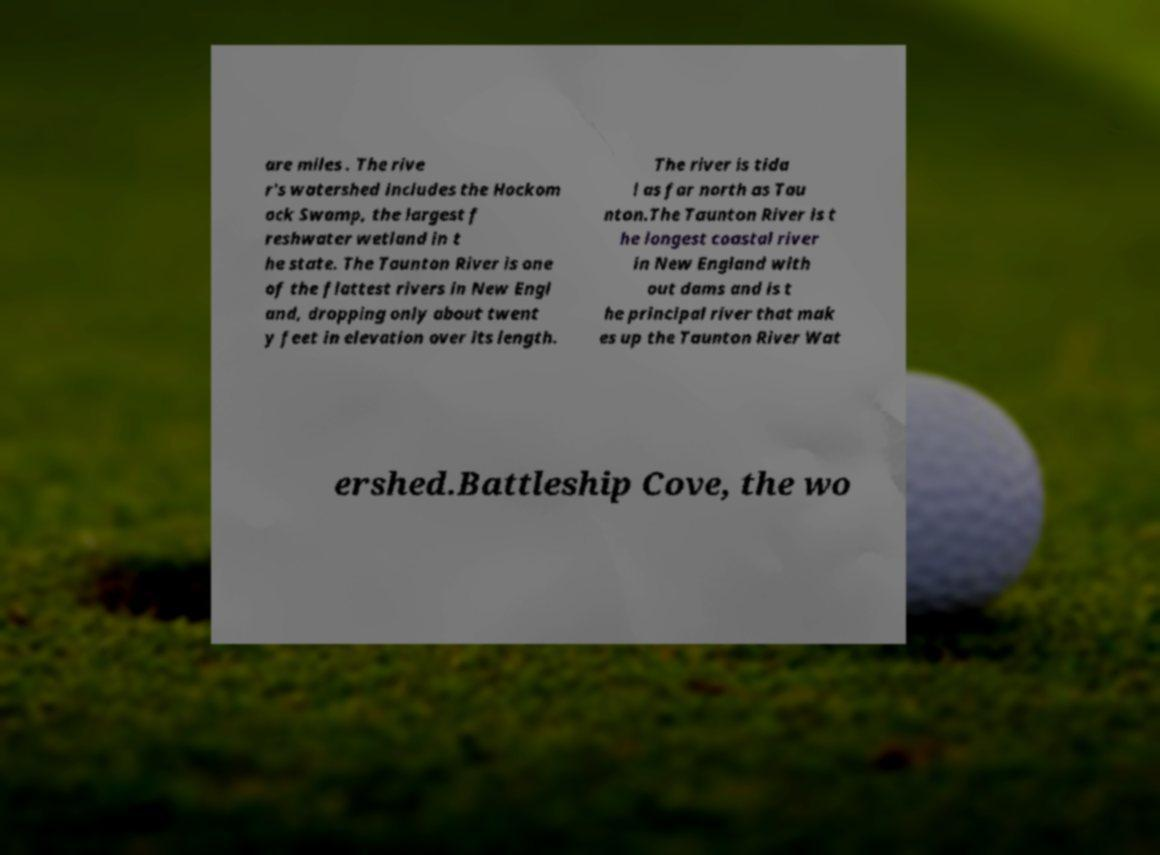For documentation purposes, I need the text within this image transcribed. Could you provide that? are miles . The rive r's watershed includes the Hockom ock Swamp, the largest f reshwater wetland in t he state. The Taunton River is one of the flattest rivers in New Engl and, dropping only about twent y feet in elevation over its length. The river is tida l as far north as Tau nton.The Taunton River is t he longest coastal river in New England with out dams and is t he principal river that mak es up the Taunton River Wat ershed.Battleship Cove, the wo 